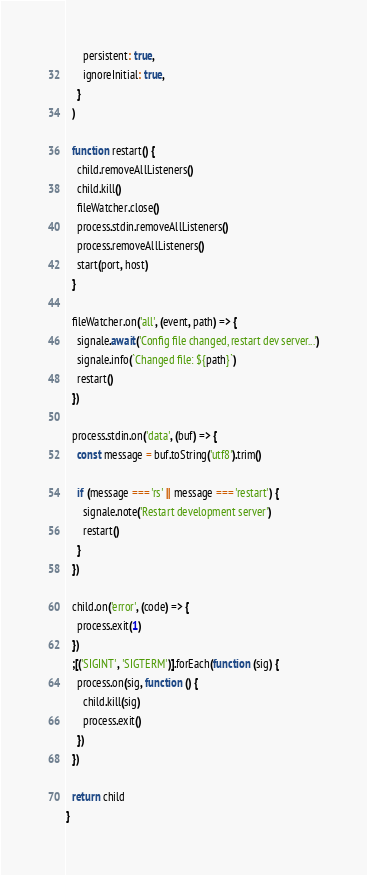<code> <loc_0><loc_0><loc_500><loc_500><_JavaScript_>      persistent: true,
      ignoreInitial: true,
    }
  )

  function restart() {
    child.removeAllListeners()
    child.kill()
    fileWatcher.close()
    process.stdin.removeAllListeners()
    process.removeAllListeners()
    start(port, host)
  }

  fileWatcher.on('all', (event, path) => {
    signale.await('Config file changed, restart dev server...')
    signale.info(`Changed file: ${path}`)
    restart()
  })

  process.stdin.on('data', (buf) => {
    const message = buf.toString('utf8').trim()

    if (message === 'rs' || message === 'restart') {
      signale.note('Restart development server')
      restart()
    }
  })

  child.on('error', (code) => {
    process.exit(1)
  })
  ;[('SIGINT', 'SIGTERM')].forEach(function (sig) {
    process.on(sig, function () {
      child.kill(sig)
      process.exit()
    })
  })

  return child
}
</code> 